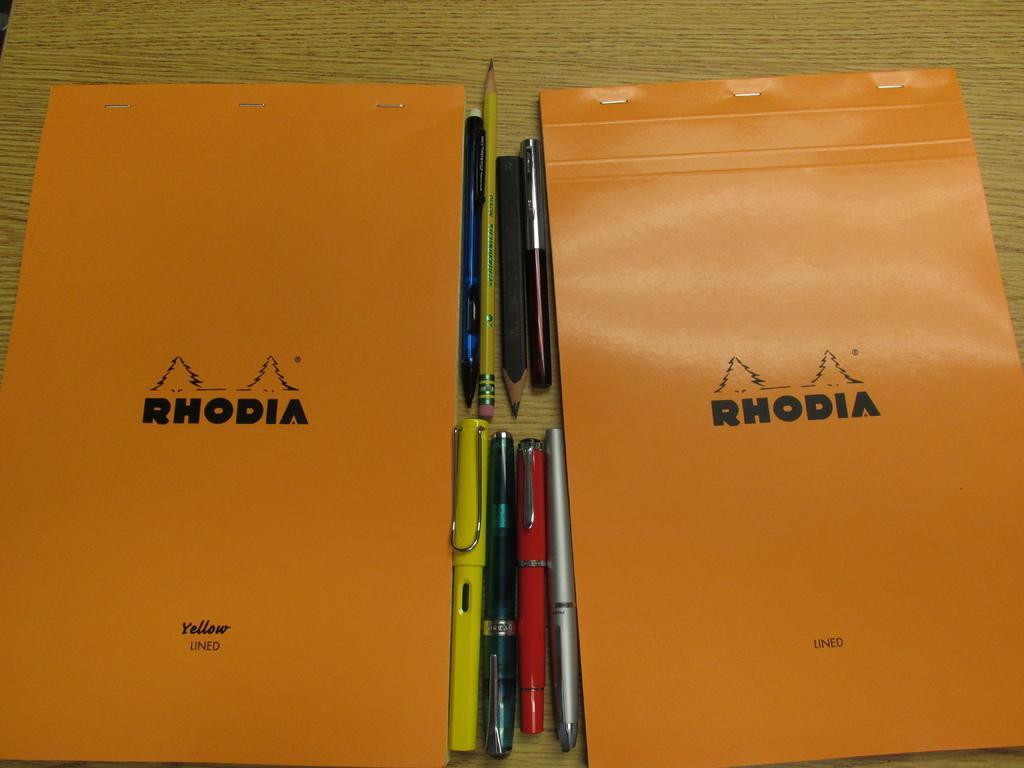Could you give a brief overview of what you see in this image? In the center of the image there is a table. On the table we can see books, pens, pencils. 